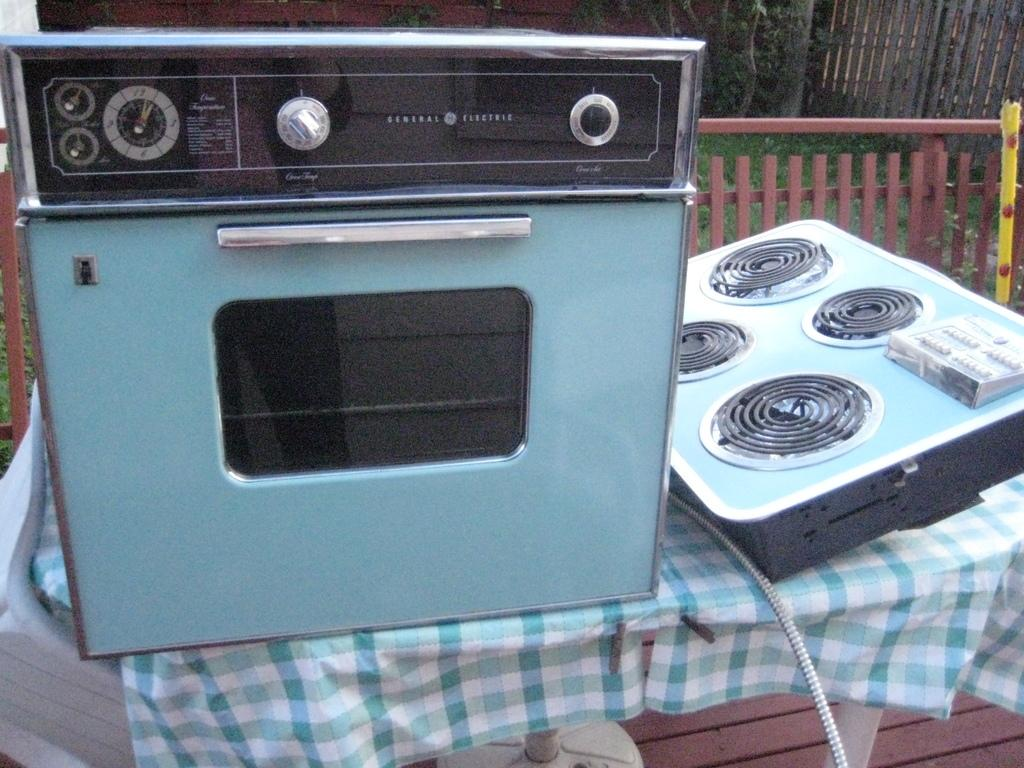<image>
Create a compact narrative representing the image presented. A General Electric oven is on a table next to a burner element. 